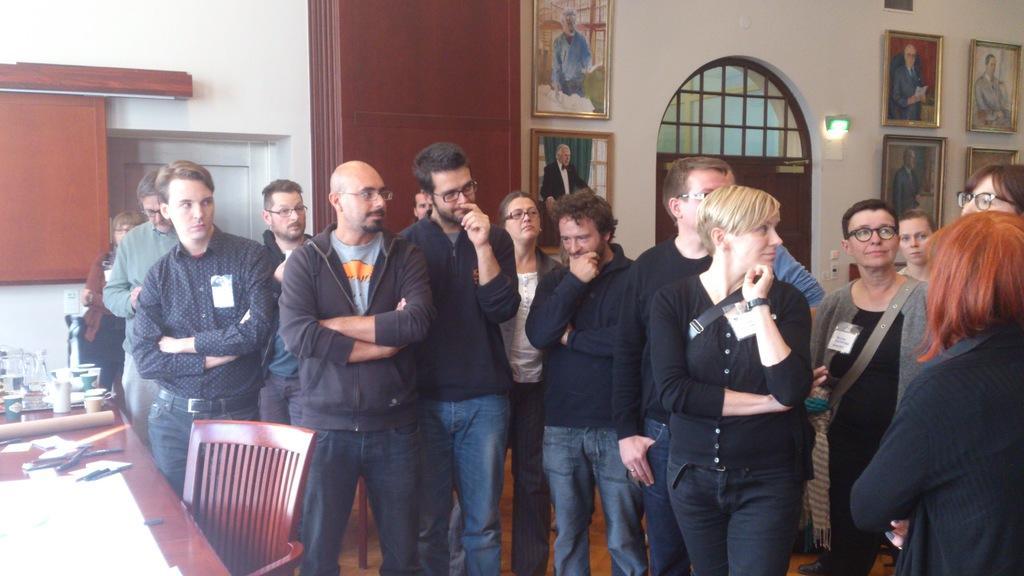Describe this image in one or two sentences. In this picture we can see a group of people standing on the floor. On the left side of the people there is a chair and a table and on the table there are papers, pens, cups and some objects. Behind the people there is a wall with photo frames, a door and some objects. 